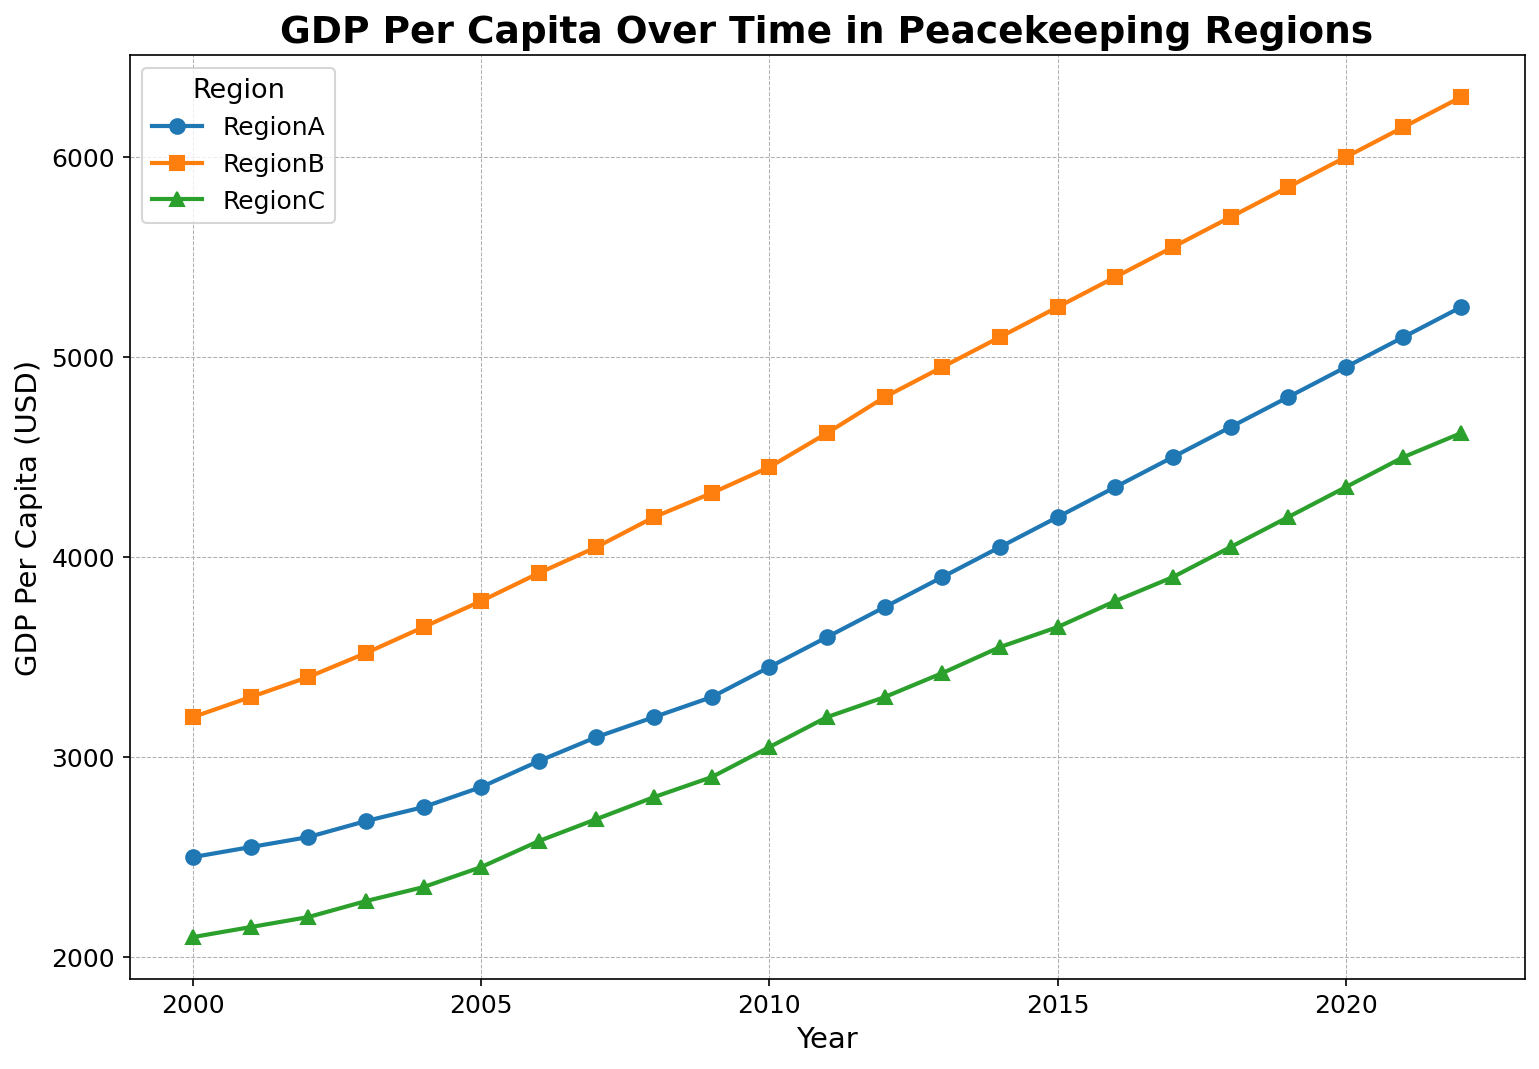What trend can you identify in the GDP per capita in RegionA over the years? From the figure, if we observe the line graph for RegionA, it steadily increases from 2000 to 2022, which indicates that the GDP per capita has been consistently growing over the years.
Answer: Increasing trend Which region shows the highest GDP per capita in 2022? Looking at the figure, the line representing RegionB is the highest point in 2022, indicating that RegionB has the highest GDP per capita among the three regions.
Answer: RegionB In which year did RegionC's GDP per capita surpass $3500? By tracking the line representing RegionC, it surpasses $3500 in the year 2014.
Answer: 2014 What is the difference between the GDP per capita of RegionB and RegionC in 2020? In 2020, the GDP per capita for RegionB is 6000, and for RegionC, it is 4350. The difference is calculated as 6000 - 4350 = 1650.
Answer: 1650 Which region saw the smallest increase in GDP per capita from 2000 to 2022? From the plot, RegionC starts at 2100 in 2000 and reaches 4620 in 2022. RegionA goes from 2500 to 5250, and RegionB goes from 3200 to 6300. The increase for RegionC is 4620 - 2100 = 2520, which is smaller than the increases observed in RegionA and RegionB.
Answer: RegionC Between which years did RegionA experience the largest single-year increase in GDP per capita? Observing the slope between points in the figure for RegionA, the largest increase appears between 2005 and 2006, where GDP per capita goes from 2850 to 2980, an increase of 130.
Answer: 2005-2006 How does the rate of growth in GDP per capita for RegionC compare to RegionA between 2010 and 2015? From the figure, RegionC’s GDP per capita grows from 3050 to 3650, a difference of 600. In the same period, RegionA's GDP per capita grows from 3450 to 4200, an increase of 750. Therefore, RegionA's growth rate is higher than RegionC’s.
Answer: RegionA's growth rate is higher What is the average GDP per capita for RegionB over the first five years (2000-2004)? From the figure, GDP per capita for RegionB from 2000 to 2004 are: 3200, 3300, 3400, 3520, 3650. The sum is 3200 + 3300 + 3400 + 3520 + 3650 = 17070. The average is 17070 / 5 = 3414.
Answer: 3414 Which region shows the most consistent growth in GDP per capita over the given period? Observing the lines in the figure, RegionB shows the most consistent linear growth without sharp increases or decreases, indicating the most steady, consistent growth.
Answer: RegionB What visual cue helps you identify RegionA's GDP per capita in the graph? The graph uses a specific color and marker for RegionA. RegionA's data points are marked using circles and are represented with a specific color (blue).
Answer: Blue circles 